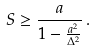<formula> <loc_0><loc_0><loc_500><loc_500>S \geq \frac { a } { 1 - \frac { a ^ { 2 } } { \Delta ^ { 2 } } } \, .</formula> 